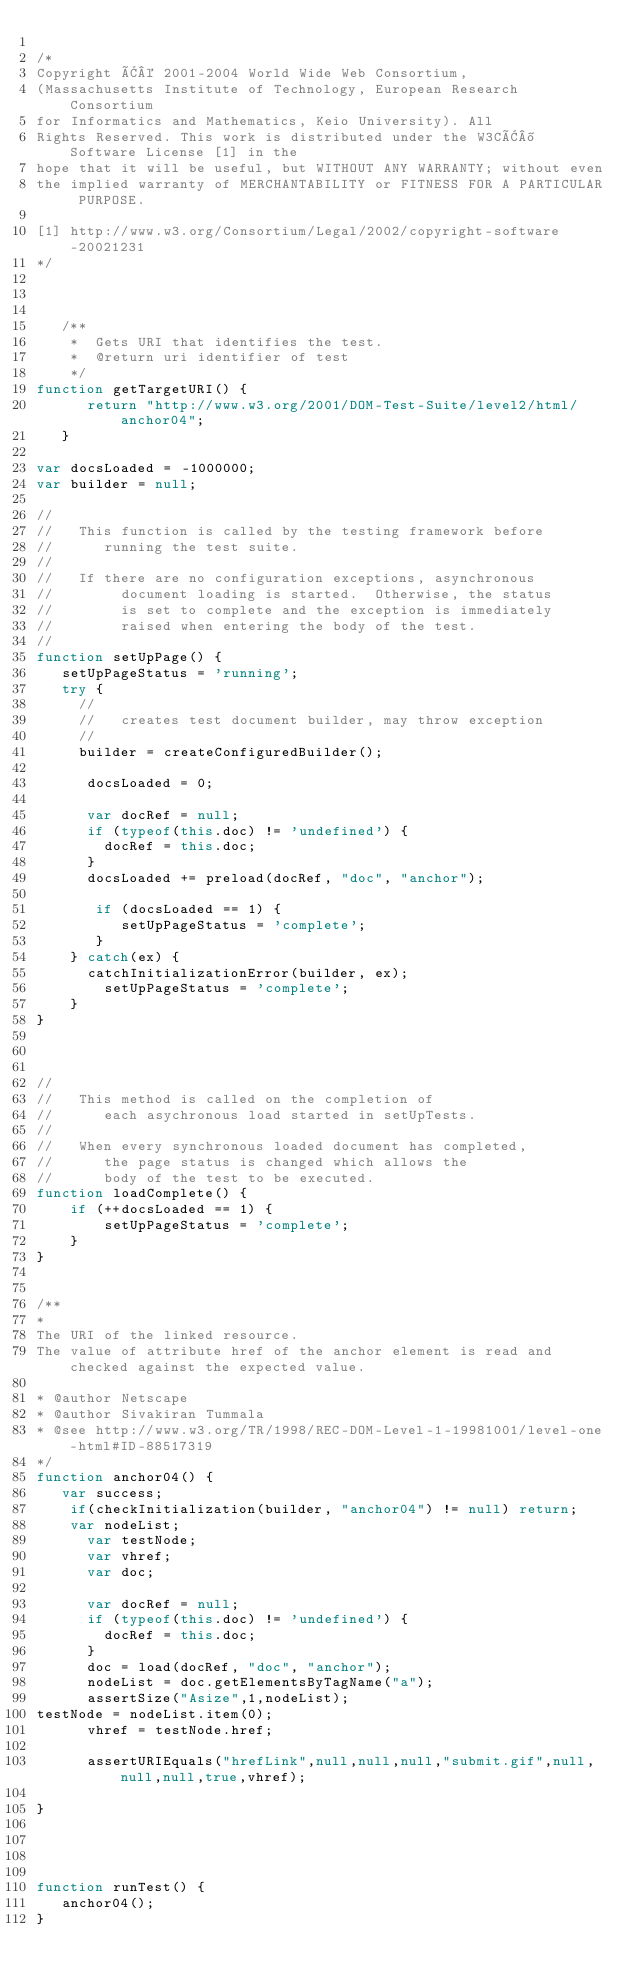<code> <loc_0><loc_0><loc_500><loc_500><_JavaScript_>
/*
Copyright Â© 2001-2004 World Wide Web Consortium, 
(Massachusetts Institute of Technology, European Research Consortium 
for Informatics and Mathematics, Keio University). All 
Rights Reserved. This work is distributed under the W3CÂ® Software License [1] in the 
hope that it will be useful, but WITHOUT ANY WARRANTY; without even 
the implied warranty of MERCHANTABILITY or FITNESS FOR A PARTICULAR PURPOSE. 

[1] http://www.w3.org/Consortium/Legal/2002/copyright-software-20021231
*/



   /**
    *  Gets URI that identifies the test.
    *  @return uri identifier of test
    */
function getTargetURI() {
      return "http://www.w3.org/2001/DOM-Test-Suite/level2/html/anchor04";
   }

var docsLoaded = -1000000;
var builder = null;

//
//   This function is called by the testing framework before
//      running the test suite.
//
//   If there are no configuration exceptions, asynchronous
//        document loading is started.  Otherwise, the status
//        is set to complete and the exception is immediately
//        raised when entering the body of the test.
//
function setUpPage() {
   setUpPageStatus = 'running';
   try {
     //
     //   creates test document builder, may throw exception
     //
     builder = createConfiguredBuilder();

      docsLoaded = 0;
      
      var docRef = null;
      if (typeof(this.doc) != 'undefined') {
        docRef = this.doc;
      }
      docsLoaded += preload(docRef, "doc", "anchor");
        
       if (docsLoaded == 1) {
          setUpPageStatus = 'complete';
       }
    } catch(ex) {
    	catchInitializationError(builder, ex);
        setUpPageStatus = 'complete';
    }
}



//
//   This method is called on the completion of 
//      each asychronous load started in setUpTests.
//
//   When every synchronous loaded document has completed,
//      the page status is changed which allows the
//      body of the test to be executed.
function loadComplete() {
    if (++docsLoaded == 1) {
        setUpPageStatus = 'complete';
    }
}


/**
* 
The URI of the linked resource.
The value of attribute href of the anchor element is read and checked against the expected value.

* @author Netscape
* @author Sivakiran Tummala
* @see http://www.w3.org/TR/1998/REC-DOM-Level-1-19981001/level-one-html#ID-88517319
*/
function anchor04() {
   var success;
    if(checkInitialization(builder, "anchor04") != null) return;
    var nodeList;
      var testNode;
      var vhref;
      var doc;
      
      var docRef = null;
      if (typeof(this.doc) != 'undefined') {
        docRef = this.doc;
      }
      doc = load(docRef, "doc", "anchor");
      nodeList = doc.getElementsByTagName("a");
      assertSize("Asize",1,nodeList);
testNode = nodeList.item(0);
      vhref = testNode.href;

      assertURIEquals("hrefLink",null,null,null,"submit.gif",null,null,null,true,vhref);

}




function runTest() {
   anchor04();
}
</code> 